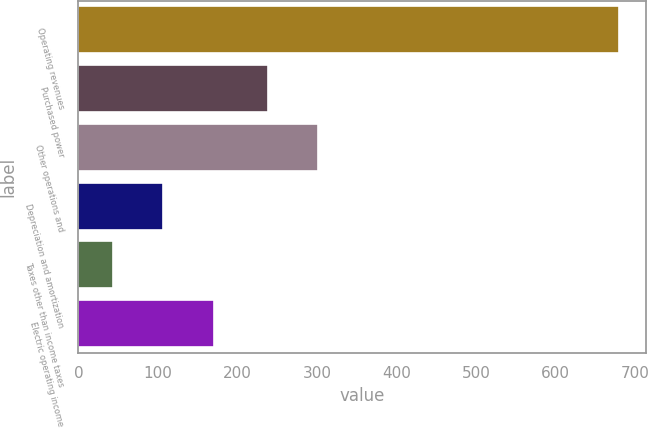Convert chart to OTSL. <chart><loc_0><loc_0><loc_500><loc_500><bar_chart><fcel>Operating revenues<fcel>Purchased power<fcel>Other operations and<fcel>Depreciation and amortization<fcel>Taxes other than income taxes<fcel>Electric operating income<nl><fcel>680<fcel>238<fcel>301.7<fcel>106.7<fcel>43<fcel>170.4<nl></chart> 